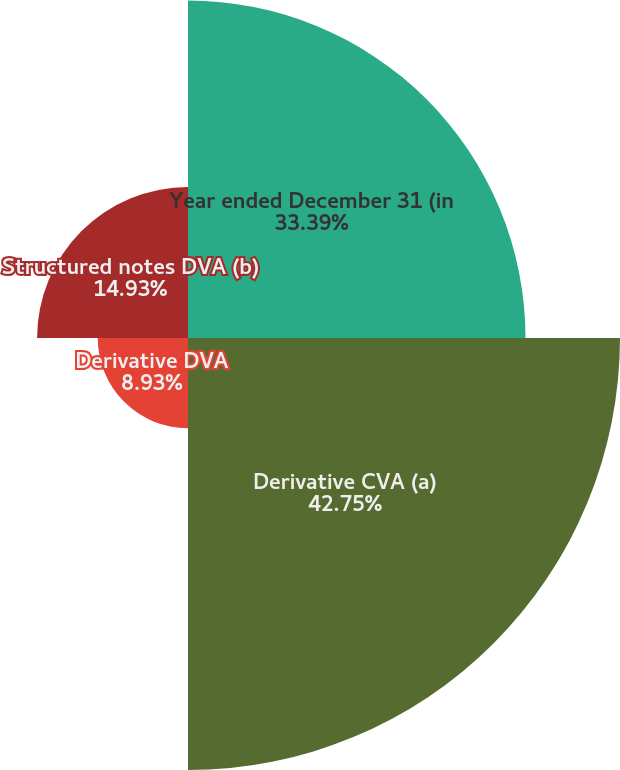<chart> <loc_0><loc_0><loc_500><loc_500><pie_chart><fcel>Year ended December 31 (in<fcel>Derivative CVA (a)<fcel>Derivative DVA<fcel>Structured notes DVA (b)<nl><fcel>33.39%<fcel>42.74%<fcel>8.93%<fcel>14.93%<nl></chart> 